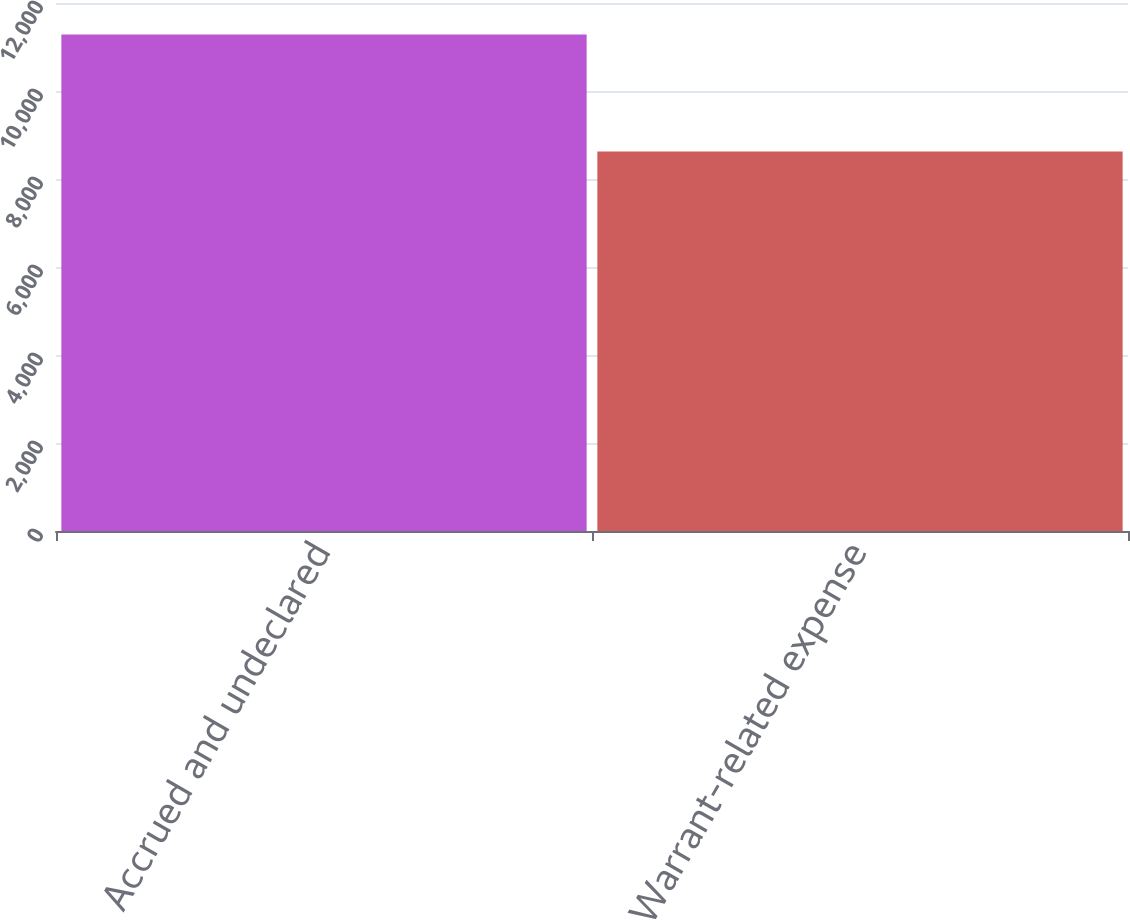<chart> <loc_0><loc_0><loc_500><loc_500><bar_chart><fcel>Accrued and undeclared<fcel>Warrant-related expense<nl><fcel>11282<fcel>8624<nl></chart> 